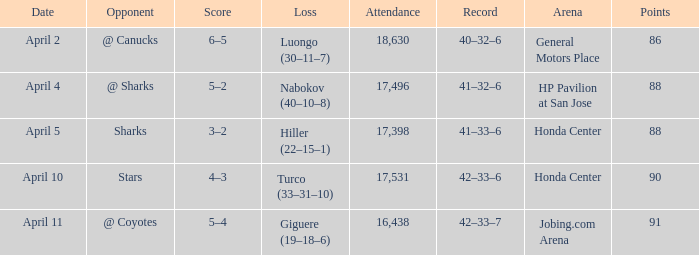On what date was the Record 41–32–6? April 4. 